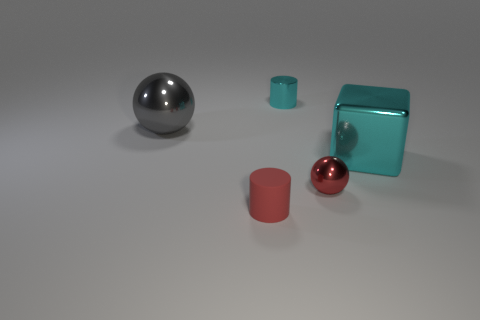What number of objects are small red matte cylinders or small cyan things? There are two objects that fit the description: one small red matte cylinder and one small cyan cube. 